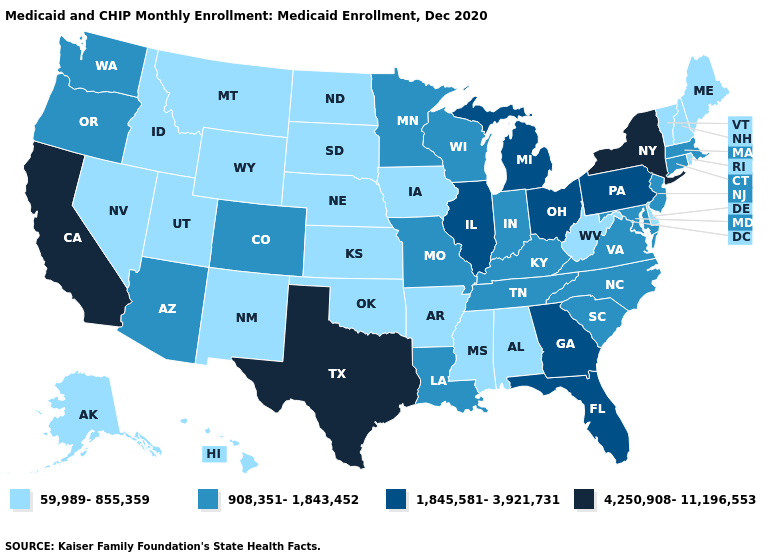What is the value of Minnesota?
Write a very short answer. 908,351-1,843,452. What is the value of New York?
Give a very brief answer. 4,250,908-11,196,553. Among the states that border Delaware , does New Jersey have the lowest value?
Short answer required. Yes. What is the value of New York?
Keep it brief. 4,250,908-11,196,553. Name the states that have a value in the range 1,845,581-3,921,731?
Be succinct. Florida, Georgia, Illinois, Michigan, Ohio, Pennsylvania. Name the states that have a value in the range 1,845,581-3,921,731?
Be succinct. Florida, Georgia, Illinois, Michigan, Ohio, Pennsylvania. Does Colorado have the lowest value in the USA?
Quick response, please. No. What is the value of Washington?
Short answer required. 908,351-1,843,452. Among the states that border Mississippi , does Arkansas have the highest value?
Short answer required. No. Is the legend a continuous bar?
Answer briefly. No. Does the map have missing data?
Keep it brief. No. What is the lowest value in the West?
Write a very short answer. 59,989-855,359. Name the states that have a value in the range 4,250,908-11,196,553?
Quick response, please. California, New York, Texas. Name the states that have a value in the range 1,845,581-3,921,731?
Keep it brief. Florida, Georgia, Illinois, Michigan, Ohio, Pennsylvania. Among the states that border Massachusetts , does New Hampshire have the highest value?
Short answer required. No. 